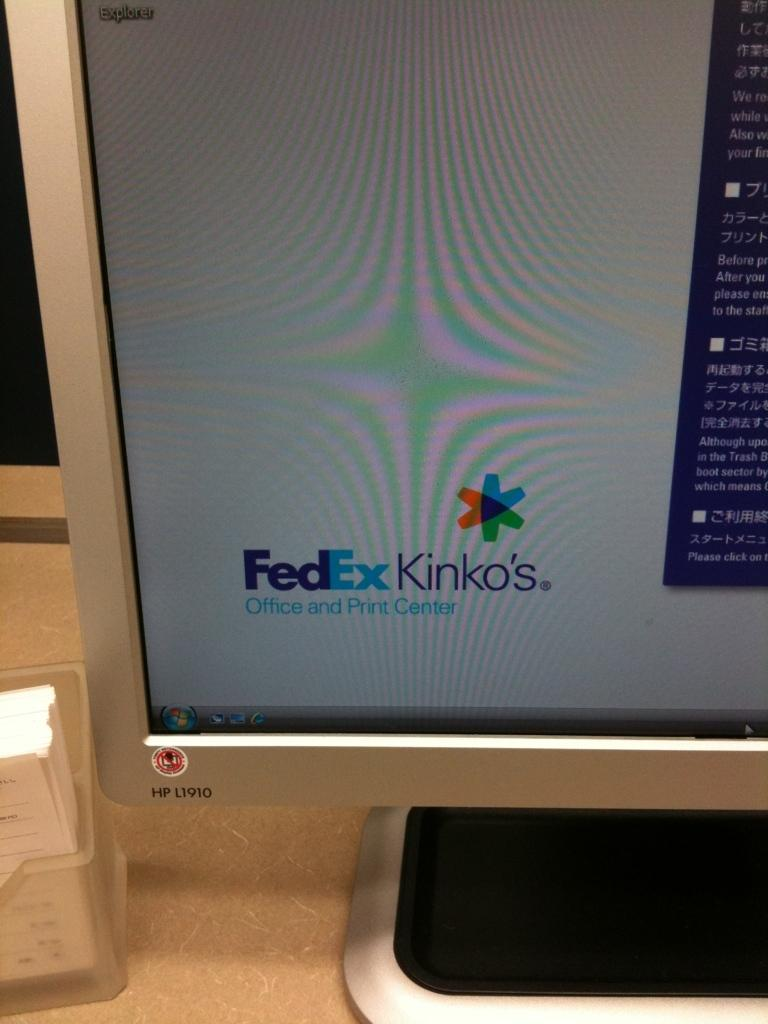Provide a one-sentence caption for the provided image. A computer monitor showing a screen for FedEx Kinko's. 